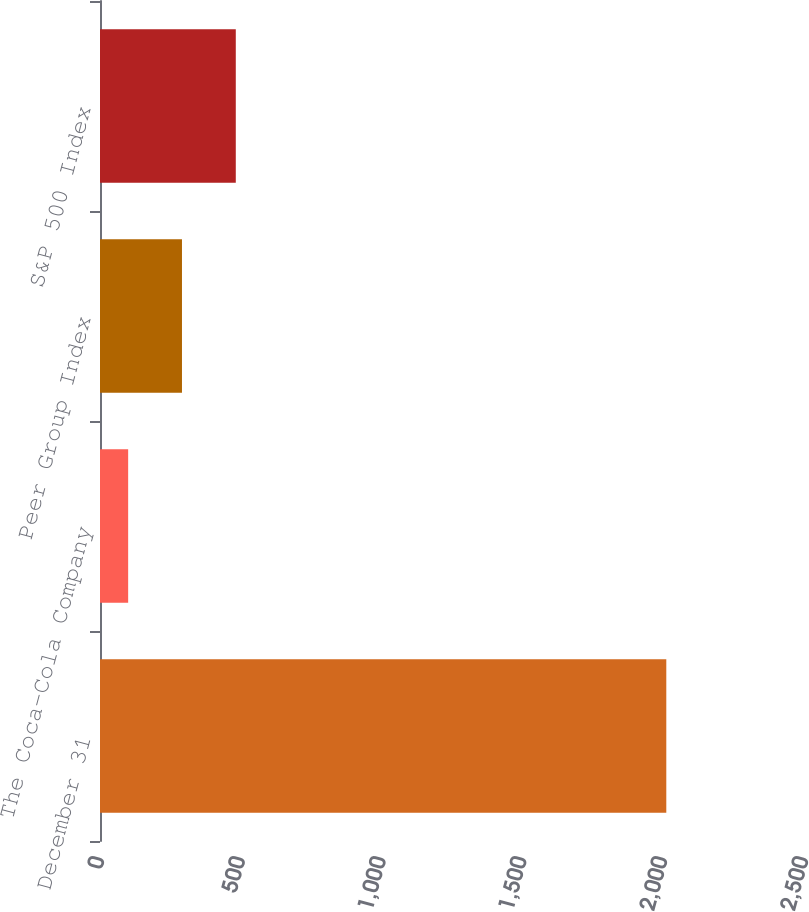Convert chart. <chart><loc_0><loc_0><loc_500><loc_500><bar_chart><fcel>December 31<fcel>The Coca-Cola Company<fcel>Peer Group Index<fcel>S&P 500 Index<nl><fcel>2011<fcel>100<fcel>291.1<fcel>482.2<nl></chart> 